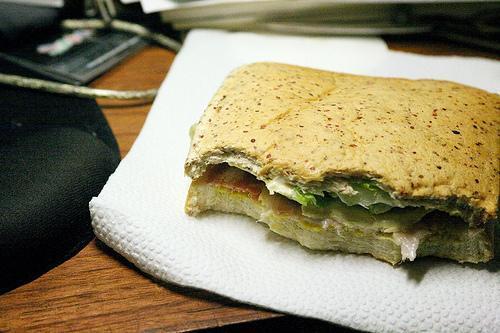How many horses are grazing on the hill?
Give a very brief answer. 0. 